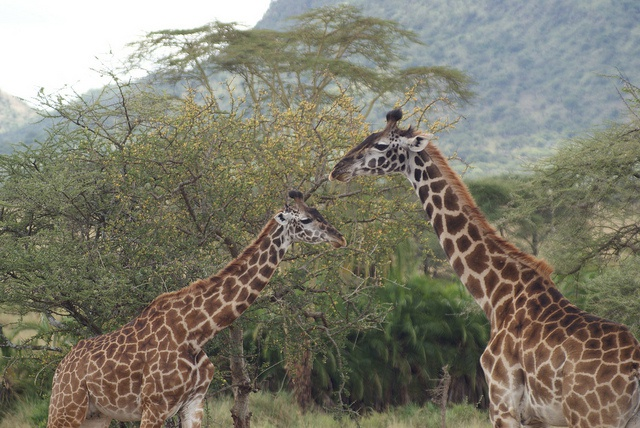Describe the objects in this image and their specific colors. I can see giraffe in white, gray, maroon, and darkgray tones and giraffe in white, gray, brown, and darkgray tones in this image. 